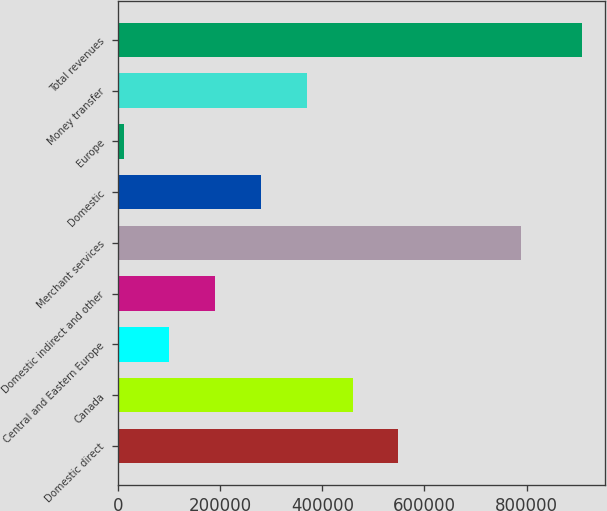Convert chart to OTSL. <chart><loc_0><loc_0><loc_500><loc_500><bar_chart><fcel>Domestic direct<fcel>Canada<fcel>Central and Eastern Europe<fcel>Domestic indirect and other<fcel>Merchant services<fcel>Domestic<fcel>Europe<fcel>Money transfer<fcel>Total revenues<nl><fcel>549029<fcel>459272<fcel>100246<fcel>190002<fcel>788500<fcel>279759<fcel>10489<fcel>369516<fcel>908056<nl></chart> 